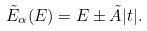<formula> <loc_0><loc_0><loc_500><loc_500>\tilde { E } _ { \alpha } ( E ) = E \pm \tilde { A } | t | .</formula> 